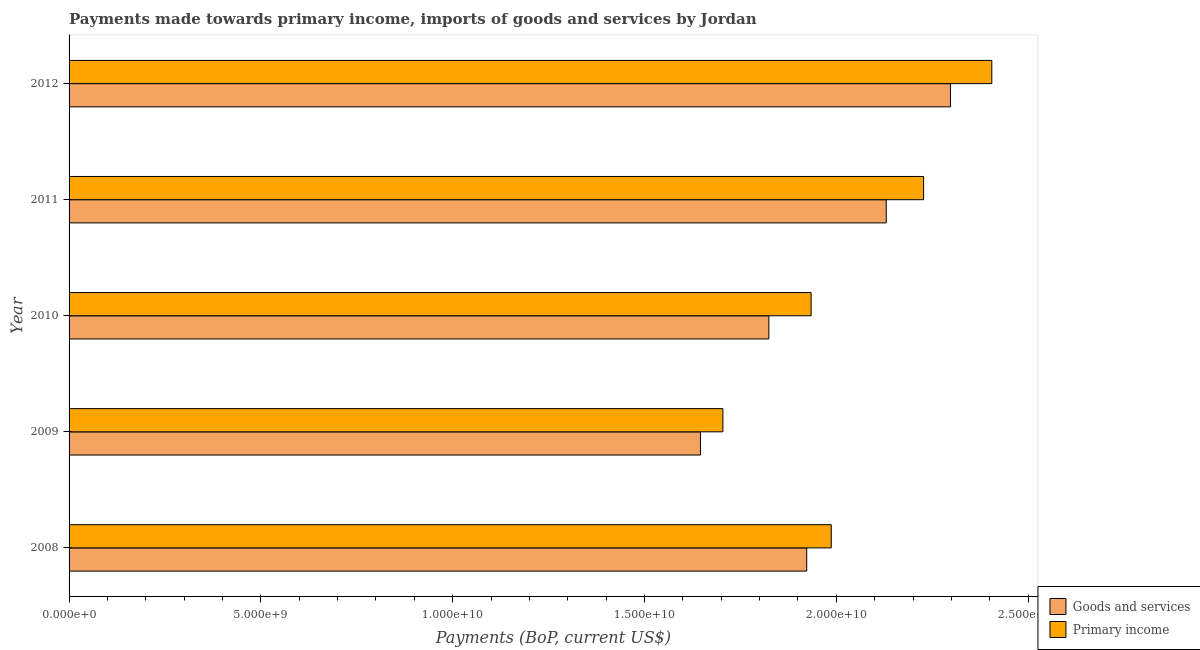Are the number of bars per tick equal to the number of legend labels?
Offer a very short reply. Yes. What is the label of the 1st group of bars from the top?
Ensure brevity in your answer.  2012. In how many cases, is the number of bars for a given year not equal to the number of legend labels?
Your response must be concise. 0. What is the payments made towards goods and services in 2011?
Your answer should be very brief. 2.13e+1. Across all years, what is the maximum payments made towards primary income?
Ensure brevity in your answer.  2.41e+1. Across all years, what is the minimum payments made towards primary income?
Your answer should be very brief. 1.70e+1. In which year was the payments made towards goods and services maximum?
Ensure brevity in your answer.  2012. What is the total payments made towards primary income in the graph?
Your response must be concise. 1.03e+11. What is the difference between the payments made towards goods and services in 2008 and that in 2012?
Offer a terse response. -3.75e+09. What is the difference between the payments made towards primary income in 2009 and the payments made towards goods and services in 2008?
Your answer should be compact. -2.18e+09. What is the average payments made towards goods and services per year?
Provide a succinct answer. 1.96e+1. In the year 2012, what is the difference between the payments made towards primary income and payments made towards goods and services?
Give a very brief answer. 1.08e+09. What is the ratio of the payments made towards goods and services in 2010 to that in 2012?
Your response must be concise. 0.79. What is the difference between the highest and the second highest payments made towards goods and services?
Your response must be concise. 1.67e+09. What is the difference between the highest and the lowest payments made towards primary income?
Give a very brief answer. 7.01e+09. In how many years, is the payments made towards goods and services greater than the average payments made towards goods and services taken over all years?
Keep it short and to the point. 2. Is the sum of the payments made towards primary income in 2009 and 2012 greater than the maximum payments made towards goods and services across all years?
Make the answer very short. Yes. What does the 1st bar from the top in 2011 represents?
Make the answer very short. Primary income. What does the 2nd bar from the bottom in 2012 represents?
Keep it short and to the point. Primary income. How many bars are there?
Provide a succinct answer. 10. Are all the bars in the graph horizontal?
Provide a succinct answer. Yes. How many legend labels are there?
Your answer should be compact. 2. What is the title of the graph?
Offer a terse response. Payments made towards primary income, imports of goods and services by Jordan. Does "Formally registered" appear as one of the legend labels in the graph?
Keep it short and to the point. No. What is the label or title of the X-axis?
Provide a succinct answer. Payments (BoP, current US$). What is the label or title of the Y-axis?
Offer a very short reply. Year. What is the Payments (BoP, current US$) in Goods and services in 2008?
Offer a terse response. 1.92e+1. What is the Payments (BoP, current US$) of Primary income in 2008?
Make the answer very short. 1.99e+1. What is the Payments (BoP, current US$) in Goods and services in 2009?
Offer a terse response. 1.65e+1. What is the Payments (BoP, current US$) of Primary income in 2009?
Give a very brief answer. 1.70e+1. What is the Payments (BoP, current US$) of Goods and services in 2010?
Offer a terse response. 1.82e+1. What is the Payments (BoP, current US$) in Primary income in 2010?
Offer a terse response. 1.93e+1. What is the Payments (BoP, current US$) of Goods and services in 2011?
Give a very brief answer. 2.13e+1. What is the Payments (BoP, current US$) in Primary income in 2011?
Your answer should be very brief. 2.23e+1. What is the Payments (BoP, current US$) in Goods and services in 2012?
Your answer should be compact. 2.30e+1. What is the Payments (BoP, current US$) in Primary income in 2012?
Offer a very short reply. 2.41e+1. Across all years, what is the maximum Payments (BoP, current US$) in Goods and services?
Give a very brief answer. 2.30e+1. Across all years, what is the maximum Payments (BoP, current US$) in Primary income?
Make the answer very short. 2.41e+1. Across all years, what is the minimum Payments (BoP, current US$) in Goods and services?
Give a very brief answer. 1.65e+1. Across all years, what is the minimum Payments (BoP, current US$) in Primary income?
Your response must be concise. 1.70e+1. What is the total Payments (BoP, current US$) in Goods and services in the graph?
Your response must be concise. 9.82e+1. What is the total Payments (BoP, current US$) in Primary income in the graph?
Your answer should be very brief. 1.03e+11. What is the difference between the Payments (BoP, current US$) of Goods and services in 2008 and that in 2009?
Offer a terse response. 2.77e+09. What is the difference between the Payments (BoP, current US$) in Primary income in 2008 and that in 2009?
Your answer should be compact. 2.82e+09. What is the difference between the Payments (BoP, current US$) of Goods and services in 2008 and that in 2010?
Your answer should be compact. 9.87e+08. What is the difference between the Payments (BoP, current US$) of Primary income in 2008 and that in 2010?
Provide a succinct answer. 5.25e+08. What is the difference between the Payments (BoP, current US$) in Goods and services in 2008 and that in 2011?
Ensure brevity in your answer.  -2.07e+09. What is the difference between the Payments (BoP, current US$) in Primary income in 2008 and that in 2011?
Your response must be concise. -2.41e+09. What is the difference between the Payments (BoP, current US$) of Goods and services in 2008 and that in 2012?
Provide a short and direct response. -3.75e+09. What is the difference between the Payments (BoP, current US$) of Primary income in 2008 and that in 2012?
Your answer should be compact. -4.18e+09. What is the difference between the Payments (BoP, current US$) of Goods and services in 2009 and that in 2010?
Make the answer very short. -1.78e+09. What is the difference between the Payments (BoP, current US$) of Primary income in 2009 and that in 2010?
Provide a short and direct response. -2.30e+09. What is the difference between the Payments (BoP, current US$) of Goods and services in 2009 and that in 2011?
Give a very brief answer. -4.84e+09. What is the difference between the Payments (BoP, current US$) in Primary income in 2009 and that in 2011?
Give a very brief answer. -5.23e+09. What is the difference between the Payments (BoP, current US$) in Goods and services in 2009 and that in 2012?
Give a very brief answer. -6.52e+09. What is the difference between the Payments (BoP, current US$) of Primary income in 2009 and that in 2012?
Provide a short and direct response. -7.01e+09. What is the difference between the Payments (BoP, current US$) of Goods and services in 2010 and that in 2011?
Your answer should be very brief. -3.06e+09. What is the difference between the Payments (BoP, current US$) in Primary income in 2010 and that in 2011?
Offer a terse response. -2.93e+09. What is the difference between the Payments (BoP, current US$) in Goods and services in 2010 and that in 2012?
Your answer should be compact. -4.73e+09. What is the difference between the Payments (BoP, current US$) of Primary income in 2010 and that in 2012?
Your answer should be compact. -4.71e+09. What is the difference between the Payments (BoP, current US$) of Goods and services in 2011 and that in 2012?
Your answer should be compact. -1.67e+09. What is the difference between the Payments (BoP, current US$) in Primary income in 2011 and that in 2012?
Offer a terse response. -1.78e+09. What is the difference between the Payments (BoP, current US$) of Goods and services in 2008 and the Payments (BoP, current US$) of Primary income in 2009?
Your answer should be very brief. 2.18e+09. What is the difference between the Payments (BoP, current US$) in Goods and services in 2008 and the Payments (BoP, current US$) in Primary income in 2010?
Make the answer very short. -1.15e+08. What is the difference between the Payments (BoP, current US$) of Goods and services in 2008 and the Payments (BoP, current US$) of Primary income in 2011?
Offer a terse response. -3.05e+09. What is the difference between the Payments (BoP, current US$) in Goods and services in 2008 and the Payments (BoP, current US$) in Primary income in 2012?
Provide a short and direct response. -4.82e+09. What is the difference between the Payments (BoP, current US$) of Goods and services in 2009 and the Payments (BoP, current US$) of Primary income in 2010?
Provide a short and direct response. -2.88e+09. What is the difference between the Payments (BoP, current US$) of Goods and services in 2009 and the Payments (BoP, current US$) of Primary income in 2011?
Your answer should be very brief. -5.82e+09. What is the difference between the Payments (BoP, current US$) of Goods and services in 2009 and the Payments (BoP, current US$) of Primary income in 2012?
Make the answer very short. -7.59e+09. What is the difference between the Payments (BoP, current US$) in Goods and services in 2010 and the Payments (BoP, current US$) in Primary income in 2011?
Offer a terse response. -4.03e+09. What is the difference between the Payments (BoP, current US$) of Goods and services in 2010 and the Payments (BoP, current US$) of Primary income in 2012?
Offer a very short reply. -5.81e+09. What is the difference between the Payments (BoP, current US$) of Goods and services in 2011 and the Payments (BoP, current US$) of Primary income in 2012?
Ensure brevity in your answer.  -2.75e+09. What is the average Payments (BoP, current US$) in Goods and services per year?
Provide a succinct answer. 1.96e+1. What is the average Payments (BoP, current US$) in Primary income per year?
Ensure brevity in your answer.  2.05e+1. In the year 2008, what is the difference between the Payments (BoP, current US$) in Goods and services and Payments (BoP, current US$) in Primary income?
Give a very brief answer. -6.40e+08. In the year 2009, what is the difference between the Payments (BoP, current US$) of Goods and services and Payments (BoP, current US$) of Primary income?
Provide a short and direct response. -5.85e+08. In the year 2010, what is the difference between the Payments (BoP, current US$) in Goods and services and Payments (BoP, current US$) in Primary income?
Offer a terse response. -1.10e+09. In the year 2011, what is the difference between the Payments (BoP, current US$) in Goods and services and Payments (BoP, current US$) in Primary income?
Provide a succinct answer. -9.75e+08. In the year 2012, what is the difference between the Payments (BoP, current US$) in Goods and services and Payments (BoP, current US$) in Primary income?
Provide a succinct answer. -1.08e+09. What is the ratio of the Payments (BoP, current US$) of Goods and services in 2008 to that in 2009?
Give a very brief answer. 1.17. What is the ratio of the Payments (BoP, current US$) of Primary income in 2008 to that in 2009?
Offer a very short reply. 1.17. What is the ratio of the Payments (BoP, current US$) of Goods and services in 2008 to that in 2010?
Provide a succinct answer. 1.05. What is the ratio of the Payments (BoP, current US$) in Primary income in 2008 to that in 2010?
Your response must be concise. 1.03. What is the ratio of the Payments (BoP, current US$) of Goods and services in 2008 to that in 2011?
Your answer should be compact. 0.9. What is the ratio of the Payments (BoP, current US$) of Primary income in 2008 to that in 2011?
Offer a terse response. 0.89. What is the ratio of the Payments (BoP, current US$) of Goods and services in 2008 to that in 2012?
Your answer should be very brief. 0.84. What is the ratio of the Payments (BoP, current US$) of Primary income in 2008 to that in 2012?
Make the answer very short. 0.83. What is the ratio of the Payments (BoP, current US$) in Goods and services in 2009 to that in 2010?
Keep it short and to the point. 0.9. What is the ratio of the Payments (BoP, current US$) of Primary income in 2009 to that in 2010?
Keep it short and to the point. 0.88. What is the ratio of the Payments (BoP, current US$) of Goods and services in 2009 to that in 2011?
Make the answer very short. 0.77. What is the ratio of the Payments (BoP, current US$) of Primary income in 2009 to that in 2011?
Make the answer very short. 0.77. What is the ratio of the Payments (BoP, current US$) in Goods and services in 2009 to that in 2012?
Keep it short and to the point. 0.72. What is the ratio of the Payments (BoP, current US$) of Primary income in 2009 to that in 2012?
Your answer should be compact. 0.71. What is the ratio of the Payments (BoP, current US$) of Goods and services in 2010 to that in 2011?
Provide a succinct answer. 0.86. What is the ratio of the Payments (BoP, current US$) in Primary income in 2010 to that in 2011?
Make the answer very short. 0.87. What is the ratio of the Payments (BoP, current US$) in Goods and services in 2010 to that in 2012?
Give a very brief answer. 0.79. What is the ratio of the Payments (BoP, current US$) in Primary income in 2010 to that in 2012?
Your answer should be compact. 0.8. What is the ratio of the Payments (BoP, current US$) of Goods and services in 2011 to that in 2012?
Give a very brief answer. 0.93. What is the ratio of the Payments (BoP, current US$) in Primary income in 2011 to that in 2012?
Offer a very short reply. 0.93. What is the difference between the highest and the second highest Payments (BoP, current US$) of Goods and services?
Keep it short and to the point. 1.67e+09. What is the difference between the highest and the second highest Payments (BoP, current US$) in Primary income?
Your response must be concise. 1.78e+09. What is the difference between the highest and the lowest Payments (BoP, current US$) of Goods and services?
Offer a very short reply. 6.52e+09. What is the difference between the highest and the lowest Payments (BoP, current US$) of Primary income?
Keep it short and to the point. 7.01e+09. 